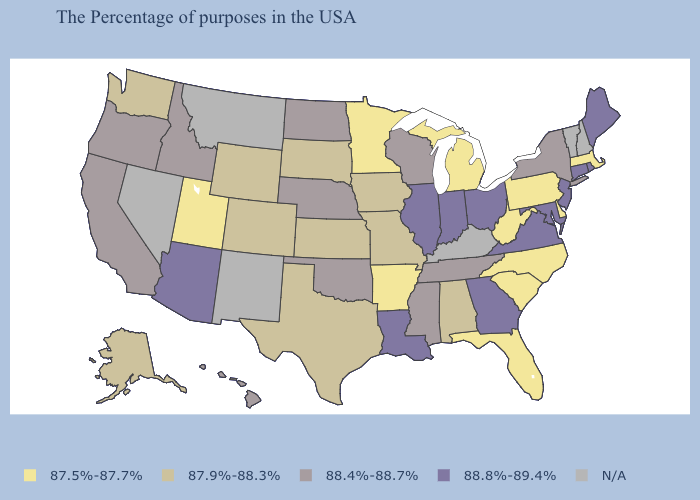What is the value of California?
Be succinct. 88.4%-88.7%. Which states have the lowest value in the MidWest?
Write a very short answer. Michigan, Minnesota. Does the first symbol in the legend represent the smallest category?
Quick response, please. Yes. Which states have the lowest value in the MidWest?
Answer briefly. Michigan, Minnesota. Which states have the lowest value in the USA?
Give a very brief answer. Massachusetts, Delaware, Pennsylvania, North Carolina, South Carolina, West Virginia, Florida, Michigan, Arkansas, Minnesota, Utah. What is the value of Wisconsin?
Answer briefly. 88.4%-88.7%. Name the states that have a value in the range N/A?
Be succinct. New Hampshire, Vermont, Kentucky, New Mexico, Montana, Nevada. Name the states that have a value in the range 88.8%-89.4%?
Answer briefly. Maine, Rhode Island, Connecticut, New Jersey, Maryland, Virginia, Ohio, Georgia, Indiana, Illinois, Louisiana, Arizona. Which states have the highest value in the USA?
Quick response, please. Maine, Rhode Island, Connecticut, New Jersey, Maryland, Virginia, Ohio, Georgia, Indiana, Illinois, Louisiana, Arizona. Which states have the lowest value in the USA?
Write a very short answer. Massachusetts, Delaware, Pennsylvania, North Carolina, South Carolina, West Virginia, Florida, Michigan, Arkansas, Minnesota, Utah. How many symbols are there in the legend?
Short answer required. 5. Does Idaho have the lowest value in the West?
Give a very brief answer. No. 